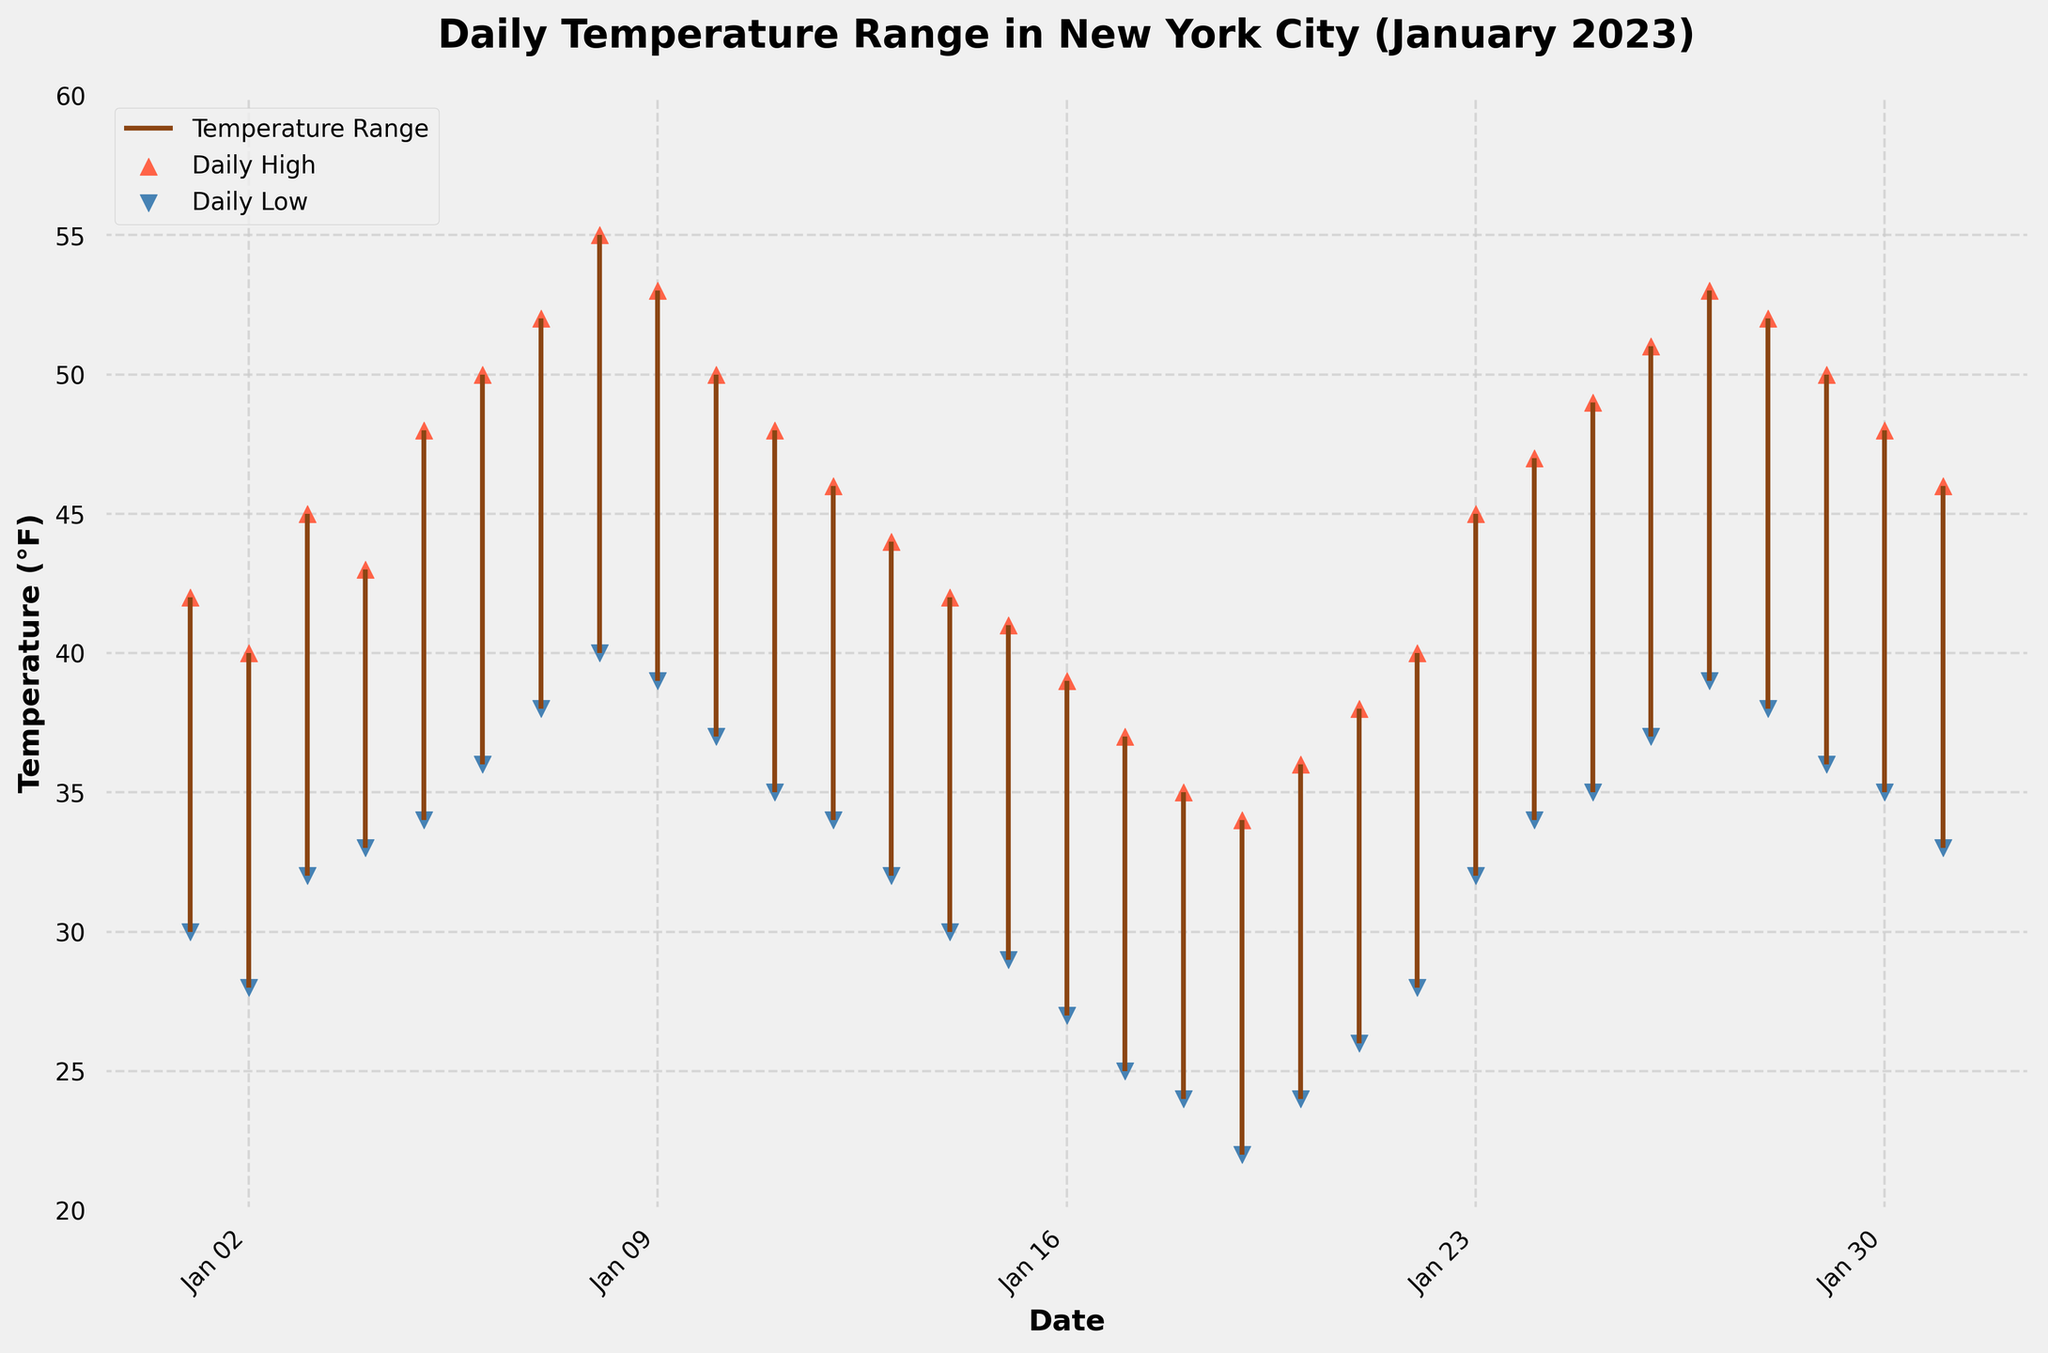What is the time period shown in the candlestick plot? The title of the plot mentions "Daily Temperature Range in New York City (January 2023)", which means the data covers January 2023. Additionally, the x-axis reflects date labels that correspond to days in January.
Answer: January 2023 What are the highest and lowest temperatures recorded? By examining the highest point of the upper markers (red triangles) and the lowest point of the lower markers (blue triangles) on the plot, we can determine the temperature range. The highest point is on January 8 with a high of 55°F, and the lowest point is on January 19 with a low of 22°F.
Answer: 55°F, 22°F On which date was the highest daily temperature recorded? By observing the highest position reached by the upper markers (red triangles) in the plot, we can identify the date. The highest daily temperature (55°F) was recorded on January 8, 2023.
Answer: January 8, 2023 What is the temperature range (difference between daily high and low) for January 20, 2023? To find the temperature range, subtract the daily low temperature from the daily high temperature on January 20, 2023. The high is 36°F and the low is 24°F, so the range is 36 - 24 = 12°F.
Answer: 12°F Which date experienced the smallest temperature range? You can determine the smallest daily temperature range by identifying the shortest vertical line between the markers from the high and low temperatures. Visual inspection shows that January 18, 2023, had the smallest range, which is from 35°F to 24°F, a range of 11°F.
Answer: January 18, 2023 How does the temperature trend vary in the second week of January compared to the first week? In the first week of January (1st-7th), there's a noticeable increasing trend in the daily high and low temperatures. In contrast, during the second week (8th-14th), temperatures peak at the beginning of the week (January 8) and then start to decrease by the end of the week.
Answer: First week temperatures increase, second week temperatures peak then decrease Which week in January shows the highest average daily low temperature? To find this, we calculate the average daily low for each week. For simplicity, assume weeks are from Sunday-Saturday:
- Week 1 (1st-7th): (30+28+32+33+34+36+38)/7 = 33.0°F
- Week 2 (8th-14th): (40+39+37+35+34+32+30)/7 = 35.29°F
- Week 3 (15th-21st): (29+27+25+24+22+24+26)/7 = 25.29°F
- Week 4 (22nd-28th): (28+32+34+35+37+39+38)/7 = 34.71°F
- Last days (29th-31st): (36+35+33)/3 = 34.67°F
The second week has the highest average daily low temperature.
Answer: Week 2 Was there any date where the daily high was below 40°F? By examining the upper markers (red triangles), January 16, 17, and 18 all had daily highs below 40°F. Each marker is below the 40°F level on y-axis.
Answer: Yes, on January 16, 17, and 18 Which day's high temperature appears closest to the average daily high of the month? First, find the average high temperature of the month: sum of all daily highs divided by 31 days. (42+40+45+43+48+50+52+55+53+50+48+46+44+42+41+39+37+35+34+36+38+40+45+47+49+51+53+52+50+48+46)/31 = 45.3°F. The high on January 3 is closest to 45.3°F with a value of 45°F.
Answer: January 3 